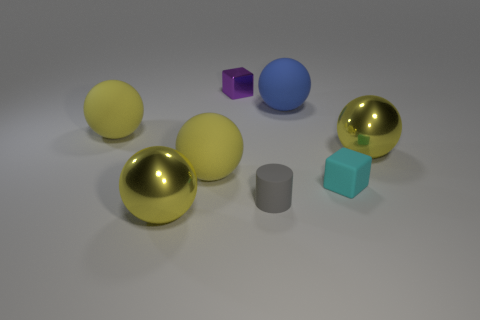There is a purple object that is the same size as the gray thing; what material is it?
Give a very brief answer. Metal. What number of gray cylinders have the same size as the cyan matte thing?
Offer a very short reply. 1. What color is the small rubber cylinder that is left of the tiny cyan object?
Your response must be concise. Gray. What number of other objects are the same size as the rubber cylinder?
Keep it short and to the point. 2. There is a rubber object that is on the right side of the tiny gray rubber cylinder and in front of the blue rubber object; how big is it?
Provide a short and direct response. Small. Are there any other matte objects of the same shape as the blue matte object?
Your response must be concise. Yes. What number of objects are either small purple metal things or yellow metal spheres that are in front of the tiny cyan rubber object?
Provide a succinct answer. 2. What number of other things are the same material as the small purple thing?
Your response must be concise. 2. How many objects are big yellow metal objects or purple blocks?
Your response must be concise. 3. Are there more yellow metallic things in front of the tiny cyan matte cube than matte cubes that are behind the big blue object?
Your response must be concise. Yes. 